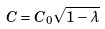Convert formula to latex. <formula><loc_0><loc_0><loc_500><loc_500>C = C _ { 0 } \sqrt { 1 - \lambda }</formula> 